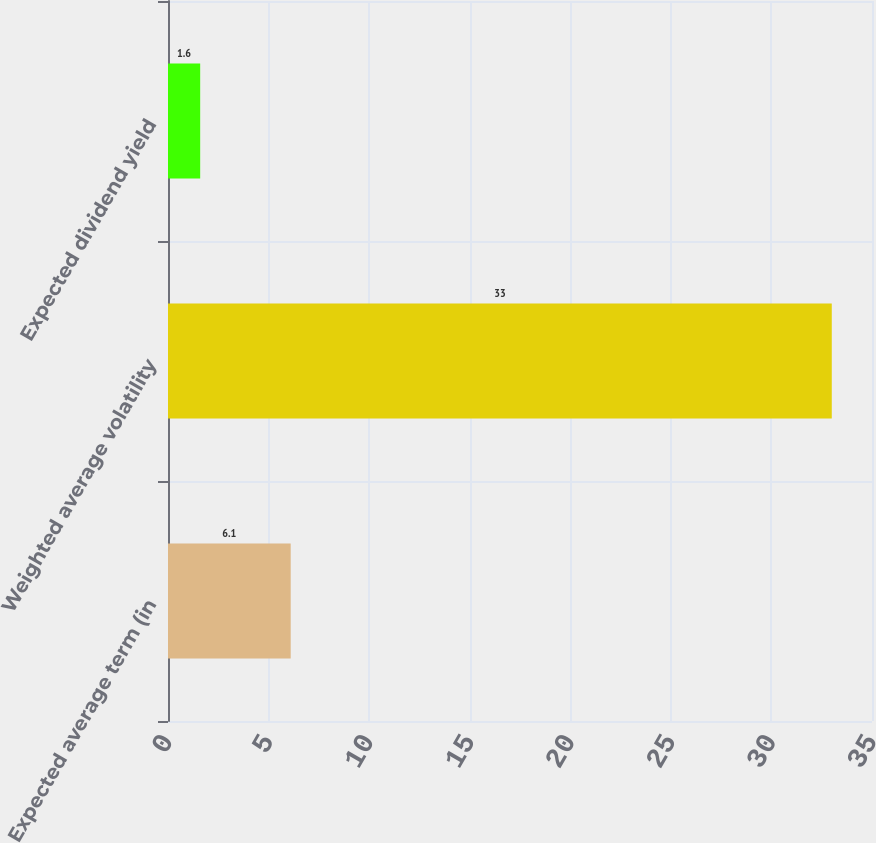<chart> <loc_0><loc_0><loc_500><loc_500><bar_chart><fcel>Expected average term (in<fcel>Weighted average volatility<fcel>Expected dividend yield<nl><fcel>6.1<fcel>33<fcel>1.6<nl></chart> 